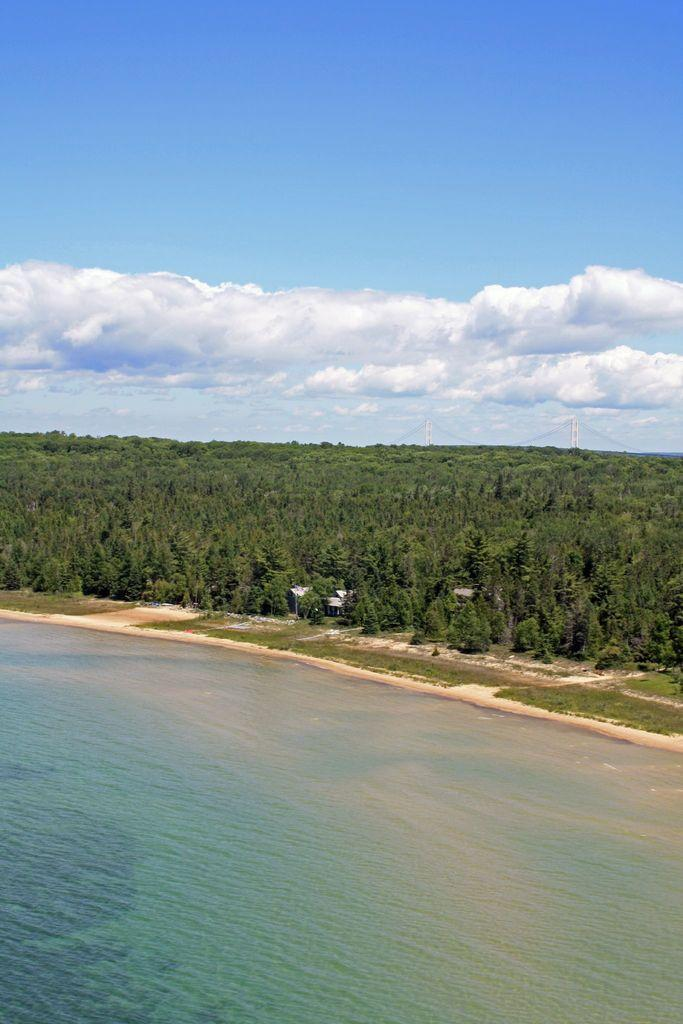What type of vegetation can be seen in the image? There are trees in the image. What else can be seen in the image besides trees? There is water and grass visible in the image. What is visible in the background of the image? The sky is visible in the background of the image. What can be seen in the sky? Clouds are present in the sky. How many pins are visible in the image? There are no pins present in the image. What type of men can be seen in the image? There are no men present in the image. 